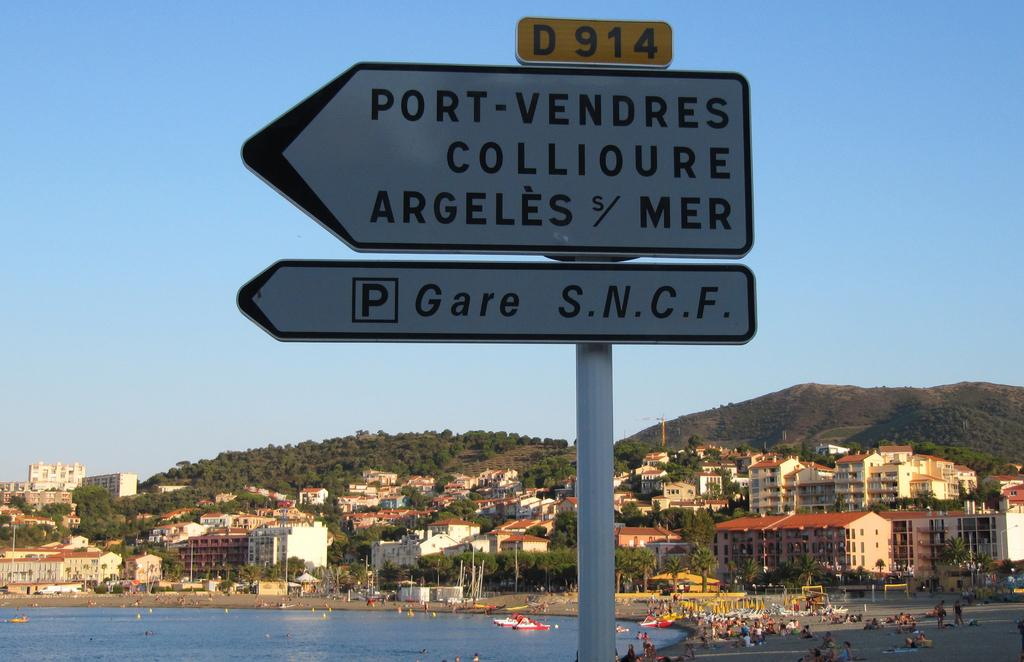<image>
Share a concise interpretation of the image provided. A sing points the way to Port-Vendres Colloure Argeles with a lake city in the background. 